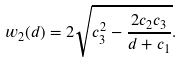Convert formula to latex. <formula><loc_0><loc_0><loc_500><loc_500>w _ { 2 } ( d ) = 2 \sqrt { c _ { 3 } ^ { 2 } - \frac { 2 c _ { 2 } c _ { 3 } } { d + c _ { 1 } } } .</formula> 